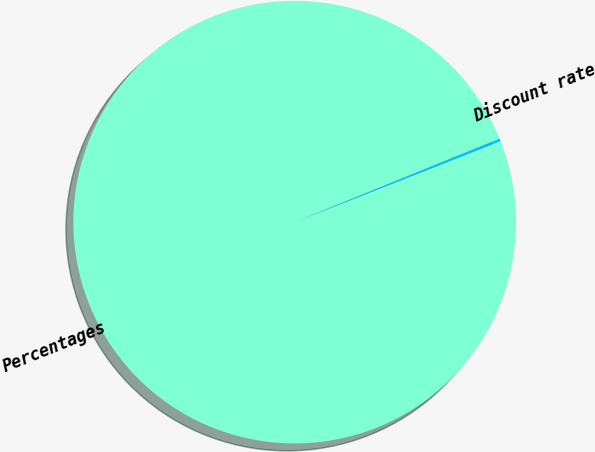Convert chart to OTSL. <chart><loc_0><loc_0><loc_500><loc_500><pie_chart><fcel>Percentages<fcel>Discount rate<nl><fcel>99.81%<fcel>0.19%<nl></chart> 